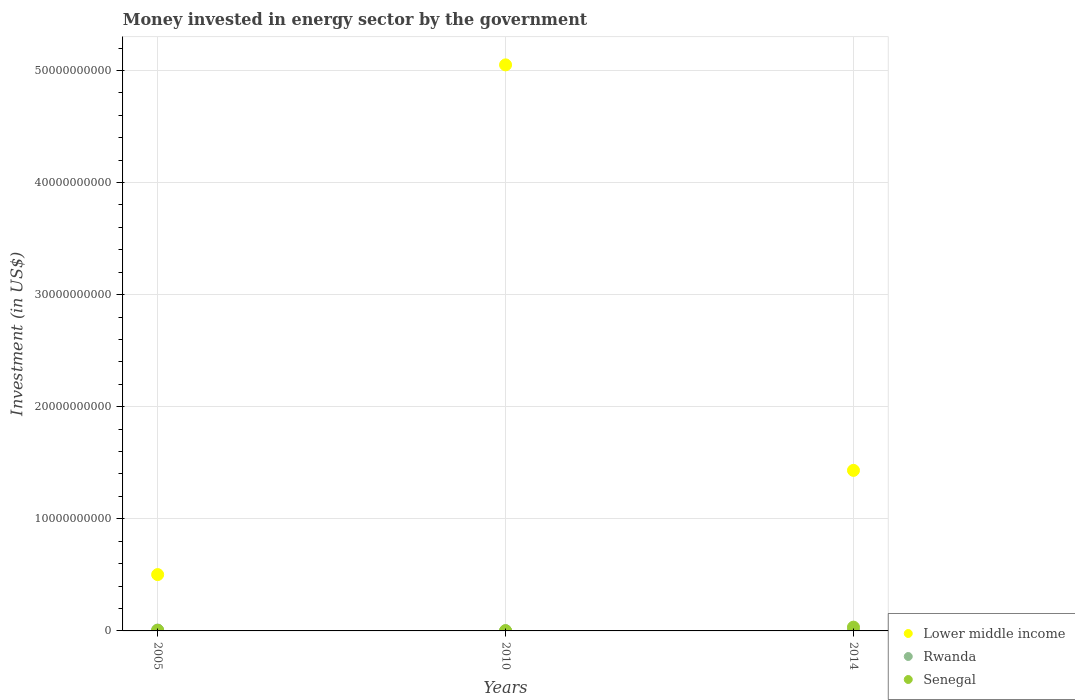How many different coloured dotlines are there?
Ensure brevity in your answer.  3. Is the number of dotlines equal to the number of legend labels?
Provide a short and direct response. Yes. What is the money spent in energy sector in Rwanda in 2005?
Ensure brevity in your answer.  7.76e+07. Across all years, what is the maximum money spent in energy sector in Rwanda?
Offer a very short reply. 7.76e+07. Across all years, what is the minimum money spent in energy sector in Rwanda?
Ensure brevity in your answer.  1.60e+07. In which year was the money spent in energy sector in Rwanda minimum?
Make the answer very short. 2010. What is the total money spent in energy sector in Lower middle income in the graph?
Your answer should be very brief. 6.98e+1. What is the difference between the money spent in energy sector in Senegal in 2005 and that in 2010?
Offer a very short reply. 3.09e+07. What is the difference between the money spent in energy sector in Senegal in 2005 and the money spent in energy sector in Rwanda in 2010?
Offer a terse response. 3.69e+07. What is the average money spent in energy sector in Lower middle income per year?
Make the answer very short. 2.33e+1. In the year 2014, what is the difference between the money spent in energy sector in Senegal and money spent in energy sector in Rwanda?
Provide a succinct answer. 3.12e+08. In how many years, is the money spent in energy sector in Lower middle income greater than 48000000000 US$?
Offer a very short reply. 1. What is the ratio of the money spent in energy sector in Lower middle income in 2005 to that in 2014?
Your response must be concise. 0.35. Is the money spent in energy sector in Lower middle income in 2005 less than that in 2010?
Make the answer very short. Yes. What is the difference between the highest and the second highest money spent in energy sector in Rwanda?
Offer a very short reply. 5.35e+07. What is the difference between the highest and the lowest money spent in energy sector in Lower middle income?
Offer a very short reply. 4.55e+1. Is the sum of the money spent in energy sector in Rwanda in 2005 and 2014 greater than the maximum money spent in energy sector in Senegal across all years?
Your response must be concise. No. Is it the case that in every year, the sum of the money spent in energy sector in Senegal and money spent in energy sector in Lower middle income  is greater than the money spent in energy sector in Rwanda?
Provide a succinct answer. Yes. Is the money spent in energy sector in Lower middle income strictly greater than the money spent in energy sector in Rwanda over the years?
Make the answer very short. Yes. How many dotlines are there?
Your answer should be very brief. 3. What is the difference between two consecutive major ticks on the Y-axis?
Provide a succinct answer. 1.00e+1. Does the graph contain grids?
Offer a very short reply. Yes. Where does the legend appear in the graph?
Give a very brief answer. Bottom right. What is the title of the graph?
Keep it short and to the point. Money invested in energy sector by the government. Does "Malaysia" appear as one of the legend labels in the graph?
Give a very brief answer. No. What is the label or title of the Y-axis?
Your answer should be very brief. Investment (in US$). What is the Investment (in US$) in Lower middle income in 2005?
Provide a succinct answer. 5.03e+09. What is the Investment (in US$) in Rwanda in 2005?
Give a very brief answer. 7.76e+07. What is the Investment (in US$) in Senegal in 2005?
Ensure brevity in your answer.  5.29e+07. What is the Investment (in US$) in Lower middle income in 2010?
Keep it short and to the point. 5.05e+1. What is the Investment (in US$) in Rwanda in 2010?
Ensure brevity in your answer.  1.60e+07. What is the Investment (in US$) of Senegal in 2010?
Your answer should be very brief. 2.20e+07. What is the Investment (in US$) of Lower middle income in 2014?
Offer a very short reply. 1.43e+1. What is the Investment (in US$) of Rwanda in 2014?
Keep it short and to the point. 2.41e+07. What is the Investment (in US$) in Senegal in 2014?
Make the answer very short. 3.36e+08. Across all years, what is the maximum Investment (in US$) in Lower middle income?
Make the answer very short. 5.05e+1. Across all years, what is the maximum Investment (in US$) of Rwanda?
Give a very brief answer. 7.76e+07. Across all years, what is the maximum Investment (in US$) in Senegal?
Keep it short and to the point. 3.36e+08. Across all years, what is the minimum Investment (in US$) in Lower middle income?
Your answer should be compact. 5.03e+09. Across all years, what is the minimum Investment (in US$) of Rwanda?
Make the answer very short. 1.60e+07. Across all years, what is the minimum Investment (in US$) in Senegal?
Your response must be concise. 2.20e+07. What is the total Investment (in US$) in Lower middle income in the graph?
Your answer should be compact. 6.98e+1. What is the total Investment (in US$) of Rwanda in the graph?
Make the answer very short. 1.18e+08. What is the total Investment (in US$) of Senegal in the graph?
Offer a terse response. 4.11e+08. What is the difference between the Investment (in US$) in Lower middle income in 2005 and that in 2010?
Provide a short and direct response. -4.55e+1. What is the difference between the Investment (in US$) in Rwanda in 2005 and that in 2010?
Offer a terse response. 6.16e+07. What is the difference between the Investment (in US$) of Senegal in 2005 and that in 2010?
Ensure brevity in your answer.  3.09e+07. What is the difference between the Investment (in US$) of Lower middle income in 2005 and that in 2014?
Offer a terse response. -9.30e+09. What is the difference between the Investment (in US$) of Rwanda in 2005 and that in 2014?
Keep it short and to the point. 5.35e+07. What is the difference between the Investment (in US$) in Senegal in 2005 and that in 2014?
Ensure brevity in your answer.  -2.83e+08. What is the difference between the Investment (in US$) of Lower middle income in 2010 and that in 2014?
Provide a succinct answer. 3.62e+1. What is the difference between the Investment (in US$) of Rwanda in 2010 and that in 2014?
Keep it short and to the point. -8.10e+06. What is the difference between the Investment (in US$) in Senegal in 2010 and that in 2014?
Make the answer very short. -3.14e+08. What is the difference between the Investment (in US$) of Lower middle income in 2005 and the Investment (in US$) of Rwanda in 2010?
Provide a succinct answer. 5.01e+09. What is the difference between the Investment (in US$) in Lower middle income in 2005 and the Investment (in US$) in Senegal in 2010?
Keep it short and to the point. 5.00e+09. What is the difference between the Investment (in US$) of Rwanda in 2005 and the Investment (in US$) of Senegal in 2010?
Offer a terse response. 5.56e+07. What is the difference between the Investment (in US$) of Lower middle income in 2005 and the Investment (in US$) of Rwanda in 2014?
Your answer should be very brief. 5.00e+09. What is the difference between the Investment (in US$) in Lower middle income in 2005 and the Investment (in US$) in Senegal in 2014?
Your answer should be very brief. 4.69e+09. What is the difference between the Investment (in US$) of Rwanda in 2005 and the Investment (in US$) of Senegal in 2014?
Make the answer very short. -2.58e+08. What is the difference between the Investment (in US$) in Lower middle income in 2010 and the Investment (in US$) in Rwanda in 2014?
Your answer should be very brief. 5.05e+1. What is the difference between the Investment (in US$) in Lower middle income in 2010 and the Investment (in US$) in Senegal in 2014?
Make the answer very short. 5.02e+1. What is the difference between the Investment (in US$) of Rwanda in 2010 and the Investment (in US$) of Senegal in 2014?
Keep it short and to the point. -3.20e+08. What is the average Investment (in US$) of Lower middle income per year?
Ensure brevity in your answer.  2.33e+1. What is the average Investment (in US$) of Rwanda per year?
Provide a short and direct response. 3.92e+07. What is the average Investment (in US$) in Senegal per year?
Keep it short and to the point. 1.37e+08. In the year 2005, what is the difference between the Investment (in US$) of Lower middle income and Investment (in US$) of Rwanda?
Provide a short and direct response. 4.95e+09. In the year 2005, what is the difference between the Investment (in US$) of Lower middle income and Investment (in US$) of Senegal?
Make the answer very short. 4.97e+09. In the year 2005, what is the difference between the Investment (in US$) in Rwanda and Investment (in US$) in Senegal?
Provide a succinct answer. 2.47e+07. In the year 2010, what is the difference between the Investment (in US$) of Lower middle income and Investment (in US$) of Rwanda?
Offer a terse response. 5.05e+1. In the year 2010, what is the difference between the Investment (in US$) of Lower middle income and Investment (in US$) of Senegal?
Make the answer very short. 5.05e+1. In the year 2010, what is the difference between the Investment (in US$) in Rwanda and Investment (in US$) in Senegal?
Provide a short and direct response. -6.00e+06. In the year 2014, what is the difference between the Investment (in US$) in Lower middle income and Investment (in US$) in Rwanda?
Ensure brevity in your answer.  1.43e+1. In the year 2014, what is the difference between the Investment (in US$) in Lower middle income and Investment (in US$) in Senegal?
Keep it short and to the point. 1.40e+1. In the year 2014, what is the difference between the Investment (in US$) of Rwanda and Investment (in US$) of Senegal?
Your answer should be very brief. -3.12e+08. What is the ratio of the Investment (in US$) of Lower middle income in 2005 to that in 2010?
Ensure brevity in your answer.  0.1. What is the ratio of the Investment (in US$) in Rwanda in 2005 to that in 2010?
Offer a terse response. 4.85. What is the ratio of the Investment (in US$) of Senegal in 2005 to that in 2010?
Make the answer very short. 2.4. What is the ratio of the Investment (in US$) in Lower middle income in 2005 to that in 2014?
Provide a short and direct response. 0.35. What is the ratio of the Investment (in US$) in Rwanda in 2005 to that in 2014?
Make the answer very short. 3.22. What is the ratio of the Investment (in US$) in Senegal in 2005 to that in 2014?
Provide a succinct answer. 0.16. What is the ratio of the Investment (in US$) in Lower middle income in 2010 to that in 2014?
Your response must be concise. 3.53. What is the ratio of the Investment (in US$) in Rwanda in 2010 to that in 2014?
Your answer should be very brief. 0.66. What is the ratio of the Investment (in US$) in Senegal in 2010 to that in 2014?
Ensure brevity in your answer.  0.07. What is the difference between the highest and the second highest Investment (in US$) in Lower middle income?
Your answer should be compact. 3.62e+1. What is the difference between the highest and the second highest Investment (in US$) of Rwanda?
Provide a short and direct response. 5.35e+07. What is the difference between the highest and the second highest Investment (in US$) of Senegal?
Keep it short and to the point. 2.83e+08. What is the difference between the highest and the lowest Investment (in US$) in Lower middle income?
Provide a short and direct response. 4.55e+1. What is the difference between the highest and the lowest Investment (in US$) in Rwanda?
Keep it short and to the point. 6.16e+07. What is the difference between the highest and the lowest Investment (in US$) in Senegal?
Give a very brief answer. 3.14e+08. 